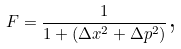Convert formula to latex. <formula><loc_0><loc_0><loc_500><loc_500>F = \frac { 1 } { 1 + ( \Delta x ^ { 2 } + \Delta p ^ { 2 } ) } \text {,}</formula> 